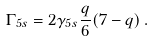<formula> <loc_0><loc_0><loc_500><loc_500>\Gamma _ { 5 s } = 2 \gamma _ { 5 s } \frac { q } { 6 } ( 7 - q ) \, .</formula> 